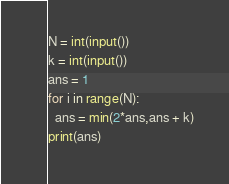<code> <loc_0><loc_0><loc_500><loc_500><_Python_>N = int(input())
k = int(input())
ans = 1
for i in range(N):
  ans = min(2*ans,ans + k)
print(ans)</code> 